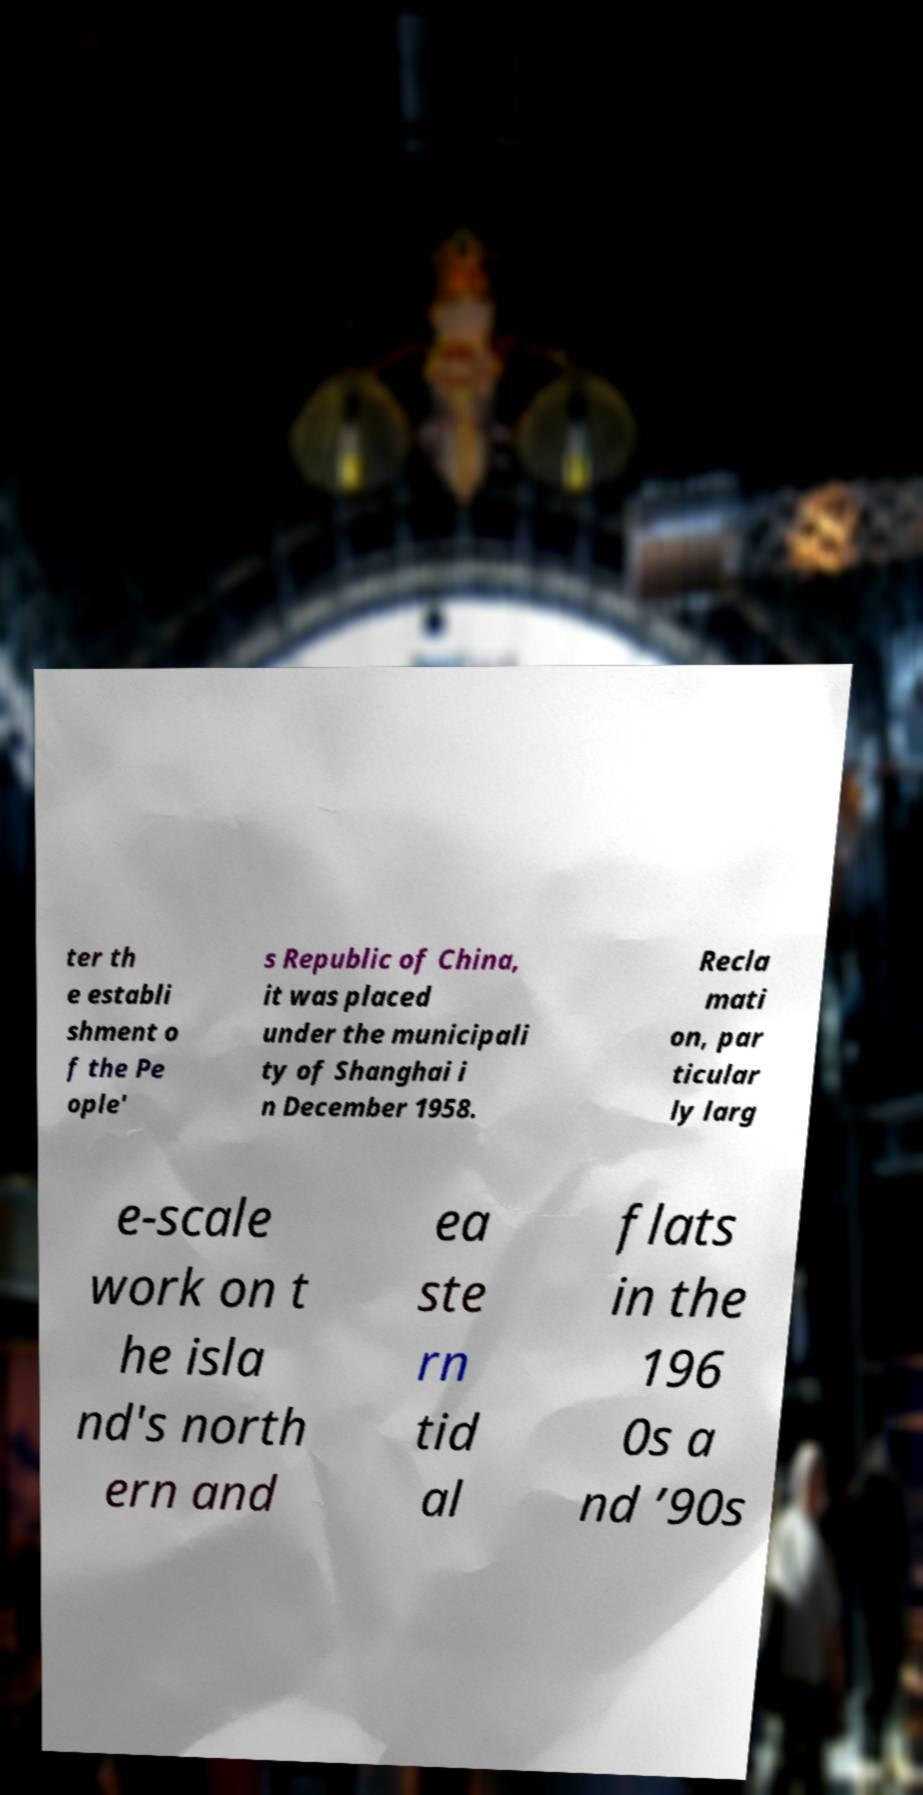For documentation purposes, I need the text within this image transcribed. Could you provide that? ter th e establi shment o f the Pe ople' s Republic of China, it was placed under the municipali ty of Shanghai i n December 1958. Recla mati on, par ticular ly larg e-scale work on t he isla nd's north ern and ea ste rn tid al flats in the 196 0s a nd ’90s 